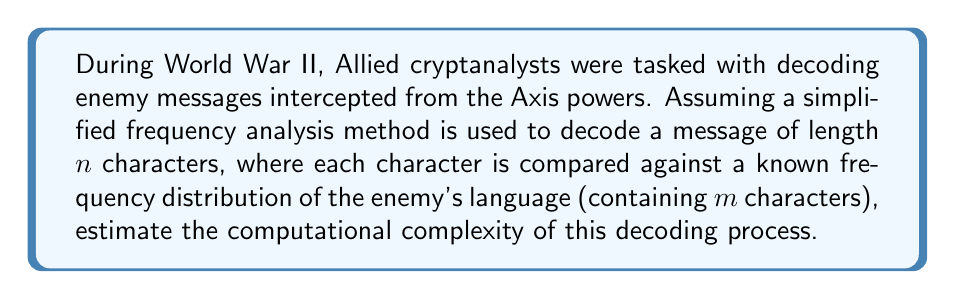Teach me how to tackle this problem. To estimate the computational complexity of decoding enemy messages using frequency analysis, we need to consider the following steps:

1. For each character in the message (total of $n$ characters):
   a. Compare it against each character in the known frequency distribution (total of $m$ characters).
   b. Update the frequency count for the matching character.

2. After processing all characters, normalize the frequency counts.

3. Match the calculated frequency distribution with the known distribution to decode the message.

Step 1 is the most computationally intensive part of this process. For each of the $n$ characters in the message, we perform $m$ comparisons. This results in a nested loop structure, giving us:

$$O(n \cdot m)$$

Step 2, normalizing the frequency counts, requires a single pass through the frequency table, which has $m$ entries. This step has a complexity of $O(m)$.

Step 3, matching the distributions, also requires comparing $m$ entries, giving another $O(m)$ complexity.

The total computational complexity is the sum of these steps:

$$O(n \cdot m) + O(m) + O(m)$$

Since $n$ (the message length) is typically much larger than $m$ (the alphabet size), the $O(n \cdot m)$ term dominates. Therefore, we can simplify the complexity to:

$$O(n \cdot m)$$

This quadratic complexity reflects the fact that for each character in the message, we need to perform operations on the entire alphabet, making frequency analysis a relatively time-consuming process for long messages or large alphabets.
Answer: $O(n \cdot m)$, where $n$ is the message length and $m$ is the number of characters in the alphabet. 